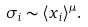Convert formula to latex. <formula><loc_0><loc_0><loc_500><loc_500>\sigma _ { i } \sim \langle x _ { i } \rangle ^ { \mu } .</formula> 